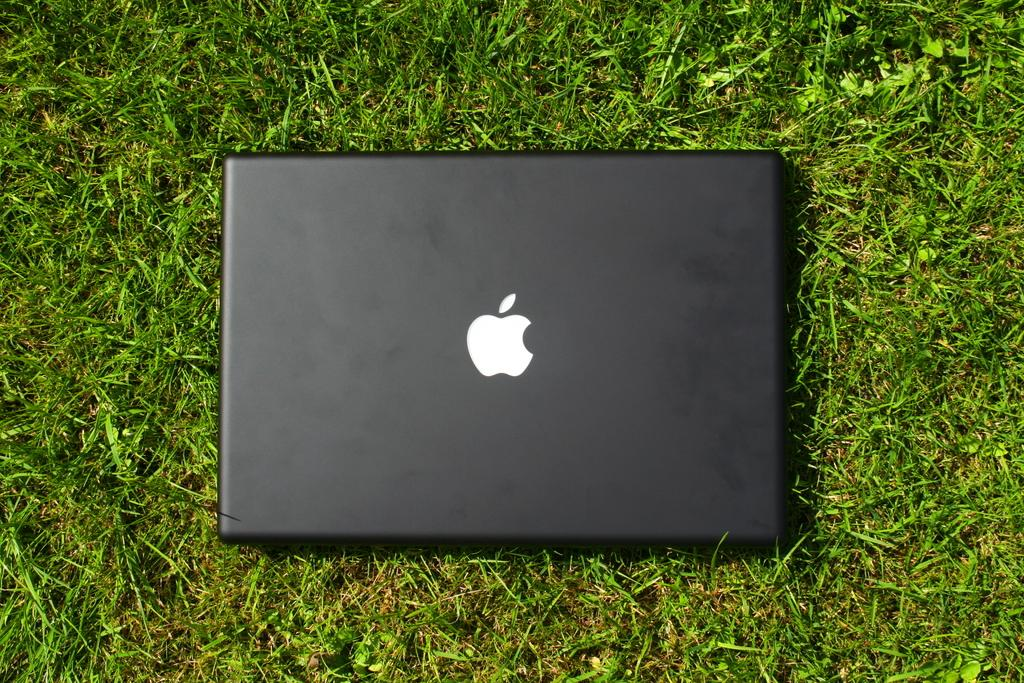What electronic device is visible in the image? There is a laptop in the image. Where is the laptop located? The laptop is on a grassland. How many cacti can be seen near the laptop in the image? There are no cacti visible in the image; the laptop is on a grassland. 